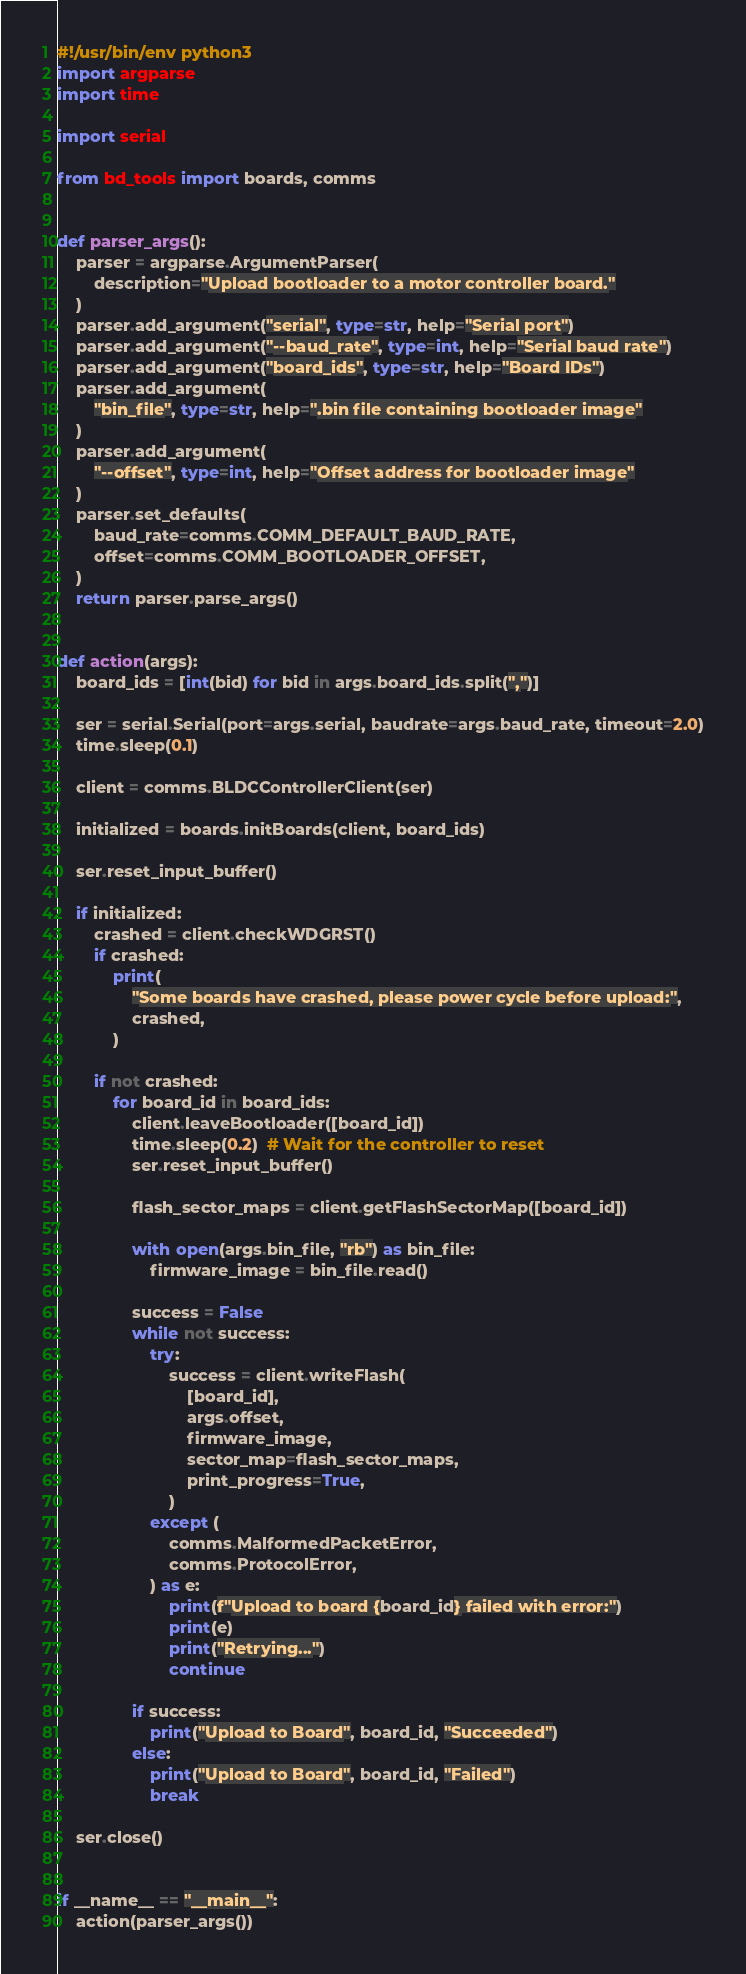Convert code to text. <code><loc_0><loc_0><loc_500><loc_500><_Python_>#!/usr/bin/env python3
import argparse
import time

import serial

from bd_tools import boards, comms


def parser_args():
    parser = argparse.ArgumentParser(
        description="Upload bootloader to a motor controller board."
    )
    parser.add_argument("serial", type=str, help="Serial port")
    parser.add_argument("--baud_rate", type=int, help="Serial baud rate")
    parser.add_argument("board_ids", type=str, help="Board IDs")
    parser.add_argument(
        "bin_file", type=str, help=".bin file containing bootloader image"
    )
    parser.add_argument(
        "--offset", type=int, help="Offset address for bootloader image"
    )
    parser.set_defaults(
        baud_rate=comms.COMM_DEFAULT_BAUD_RATE,
        offset=comms.COMM_BOOTLOADER_OFFSET,
    )
    return parser.parse_args()


def action(args):
    board_ids = [int(bid) for bid in args.board_ids.split(",")]

    ser = serial.Serial(port=args.serial, baudrate=args.baud_rate, timeout=2.0)
    time.sleep(0.1)

    client = comms.BLDCControllerClient(ser)

    initialized = boards.initBoards(client, board_ids)

    ser.reset_input_buffer()

    if initialized:
        crashed = client.checkWDGRST()
        if crashed:
            print(
                "Some boards have crashed, please power cycle before upload:",
                crashed,
            )

        if not crashed:
            for board_id in board_ids:
                client.leaveBootloader([board_id])
                time.sleep(0.2)  # Wait for the controller to reset
                ser.reset_input_buffer()

                flash_sector_maps = client.getFlashSectorMap([board_id])

                with open(args.bin_file, "rb") as bin_file:
                    firmware_image = bin_file.read()

                success = False
                while not success:
                    try:
                        success = client.writeFlash(
                            [board_id],
                            args.offset,
                            firmware_image,
                            sector_map=flash_sector_maps,
                            print_progress=True,
                        )
                    except (
                        comms.MalformedPacketError,
                        comms.ProtocolError,
                    ) as e:
                        print(f"Upload to board {board_id} failed with error:")
                        print(e)
                        print("Retrying...")
                        continue

                if success:
                    print("Upload to Board", board_id, "Succeeded")
                else:
                    print("Upload to Board", board_id, "Failed")
                    break

    ser.close()


if __name__ == "__main__":
    action(parser_args())
</code> 